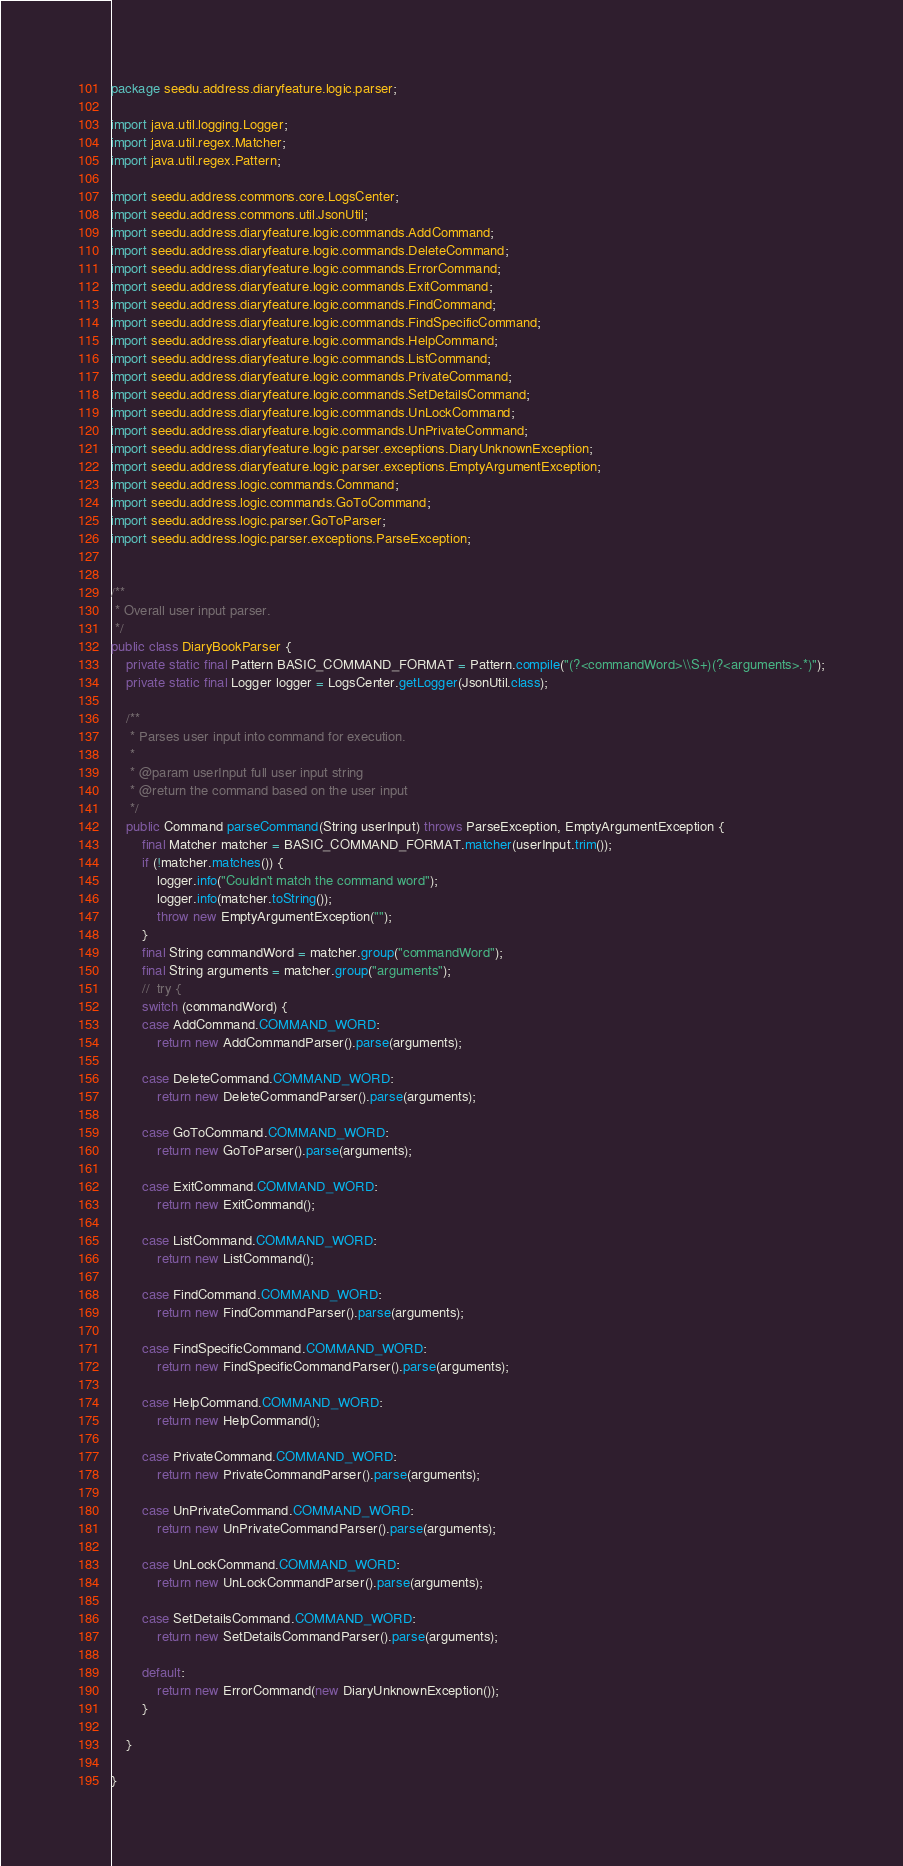<code> <loc_0><loc_0><loc_500><loc_500><_Java_>package seedu.address.diaryfeature.logic.parser;

import java.util.logging.Logger;
import java.util.regex.Matcher;
import java.util.regex.Pattern;

import seedu.address.commons.core.LogsCenter;
import seedu.address.commons.util.JsonUtil;
import seedu.address.diaryfeature.logic.commands.AddCommand;
import seedu.address.diaryfeature.logic.commands.DeleteCommand;
import seedu.address.diaryfeature.logic.commands.ErrorCommand;
import seedu.address.diaryfeature.logic.commands.ExitCommand;
import seedu.address.diaryfeature.logic.commands.FindCommand;
import seedu.address.diaryfeature.logic.commands.FindSpecificCommand;
import seedu.address.diaryfeature.logic.commands.HelpCommand;
import seedu.address.diaryfeature.logic.commands.ListCommand;
import seedu.address.diaryfeature.logic.commands.PrivateCommand;
import seedu.address.diaryfeature.logic.commands.SetDetailsCommand;
import seedu.address.diaryfeature.logic.commands.UnLockCommand;
import seedu.address.diaryfeature.logic.commands.UnPrivateCommand;
import seedu.address.diaryfeature.logic.parser.exceptions.DiaryUnknownException;
import seedu.address.diaryfeature.logic.parser.exceptions.EmptyArgumentException;
import seedu.address.logic.commands.Command;
import seedu.address.logic.commands.GoToCommand;
import seedu.address.logic.parser.GoToParser;
import seedu.address.logic.parser.exceptions.ParseException;


/**
 * Overall user input parser.
 */
public class DiaryBookParser {
    private static final Pattern BASIC_COMMAND_FORMAT = Pattern.compile("(?<commandWord>\\S+)(?<arguments>.*)");
    private static final Logger logger = LogsCenter.getLogger(JsonUtil.class);

    /**
     * Parses user input into command for execution.
     *
     * @param userInput full user input string
     * @return the command based on the user input
     */
    public Command parseCommand(String userInput) throws ParseException, EmptyArgumentException {
        final Matcher matcher = BASIC_COMMAND_FORMAT.matcher(userInput.trim());
        if (!matcher.matches()) {
            logger.info("Couldn't match the command word");
            logger.info(matcher.toString());
            throw new EmptyArgumentException("");
        }
        final String commandWord = matcher.group("commandWord");
        final String arguments = matcher.group("arguments");
        //  try {
        switch (commandWord) {
        case AddCommand.COMMAND_WORD:
            return new AddCommandParser().parse(arguments);

        case DeleteCommand.COMMAND_WORD:
            return new DeleteCommandParser().parse(arguments);

        case GoToCommand.COMMAND_WORD:
            return new GoToParser().parse(arguments);

        case ExitCommand.COMMAND_WORD:
            return new ExitCommand();

        case ListCommand.COMMAND_WORD:
            return new ListCommand();

        case FindCommand.COMMAND_WORD:
            return new FindCommandParser().parse(arguments);

        case FindSpecificCommand.COMMAND_WORD:
            return new FindSpecificCommandParser().parse(arguments);

        case HelpCommand.COMMAND_WORD:
            return new HelpCommand();

        case PrivateCommand.COMMAND_WORD:
            return new PrivateCommandParser().parse(arguments);

        case UnPrivateCommand.COMMAND_WORD:
            return new UnPrivateCommandParser().parse(arguments);

        case UnLockCommand.COMMAND_WORD:
            return new UnLockCommandParser().parse(arguments);

        case SetDetailsCommand.COMMAND_WORD:
            return new SetDetailsCommandParser().parse(arguments);

        default:
            return new ErrorCommand(new DiaryUnknownException());
        }

    }

}
</code> 